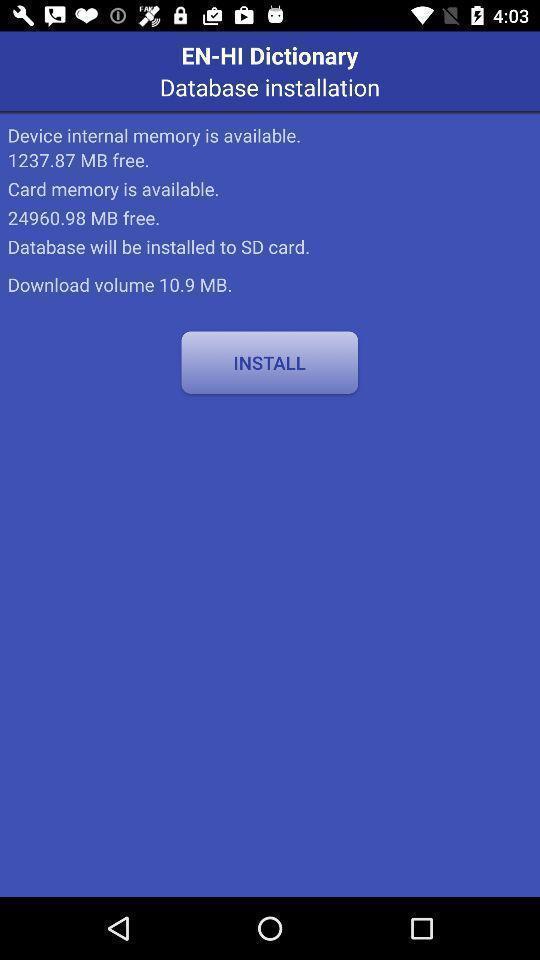Tell me about the visual elements in this screen capture. Screen displaying information about the dictionary application. 